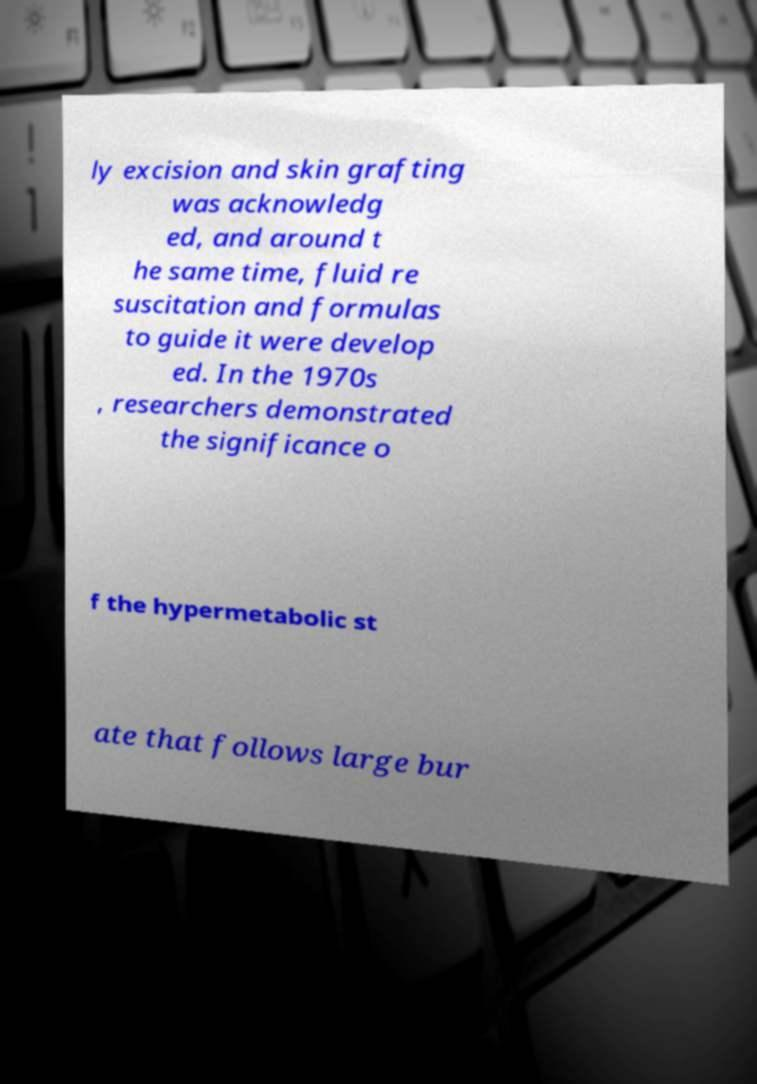Could you assist in decoding the text presented in this image and type it out clearly? ly excision and skin grafting was acknowledg ed, and around t he same time, fluid re suscitation and formulas to guide it were develop ed. In the 1970s , researchers demonstrated the significance o f the hypermetabolic st ate that follows large bur 